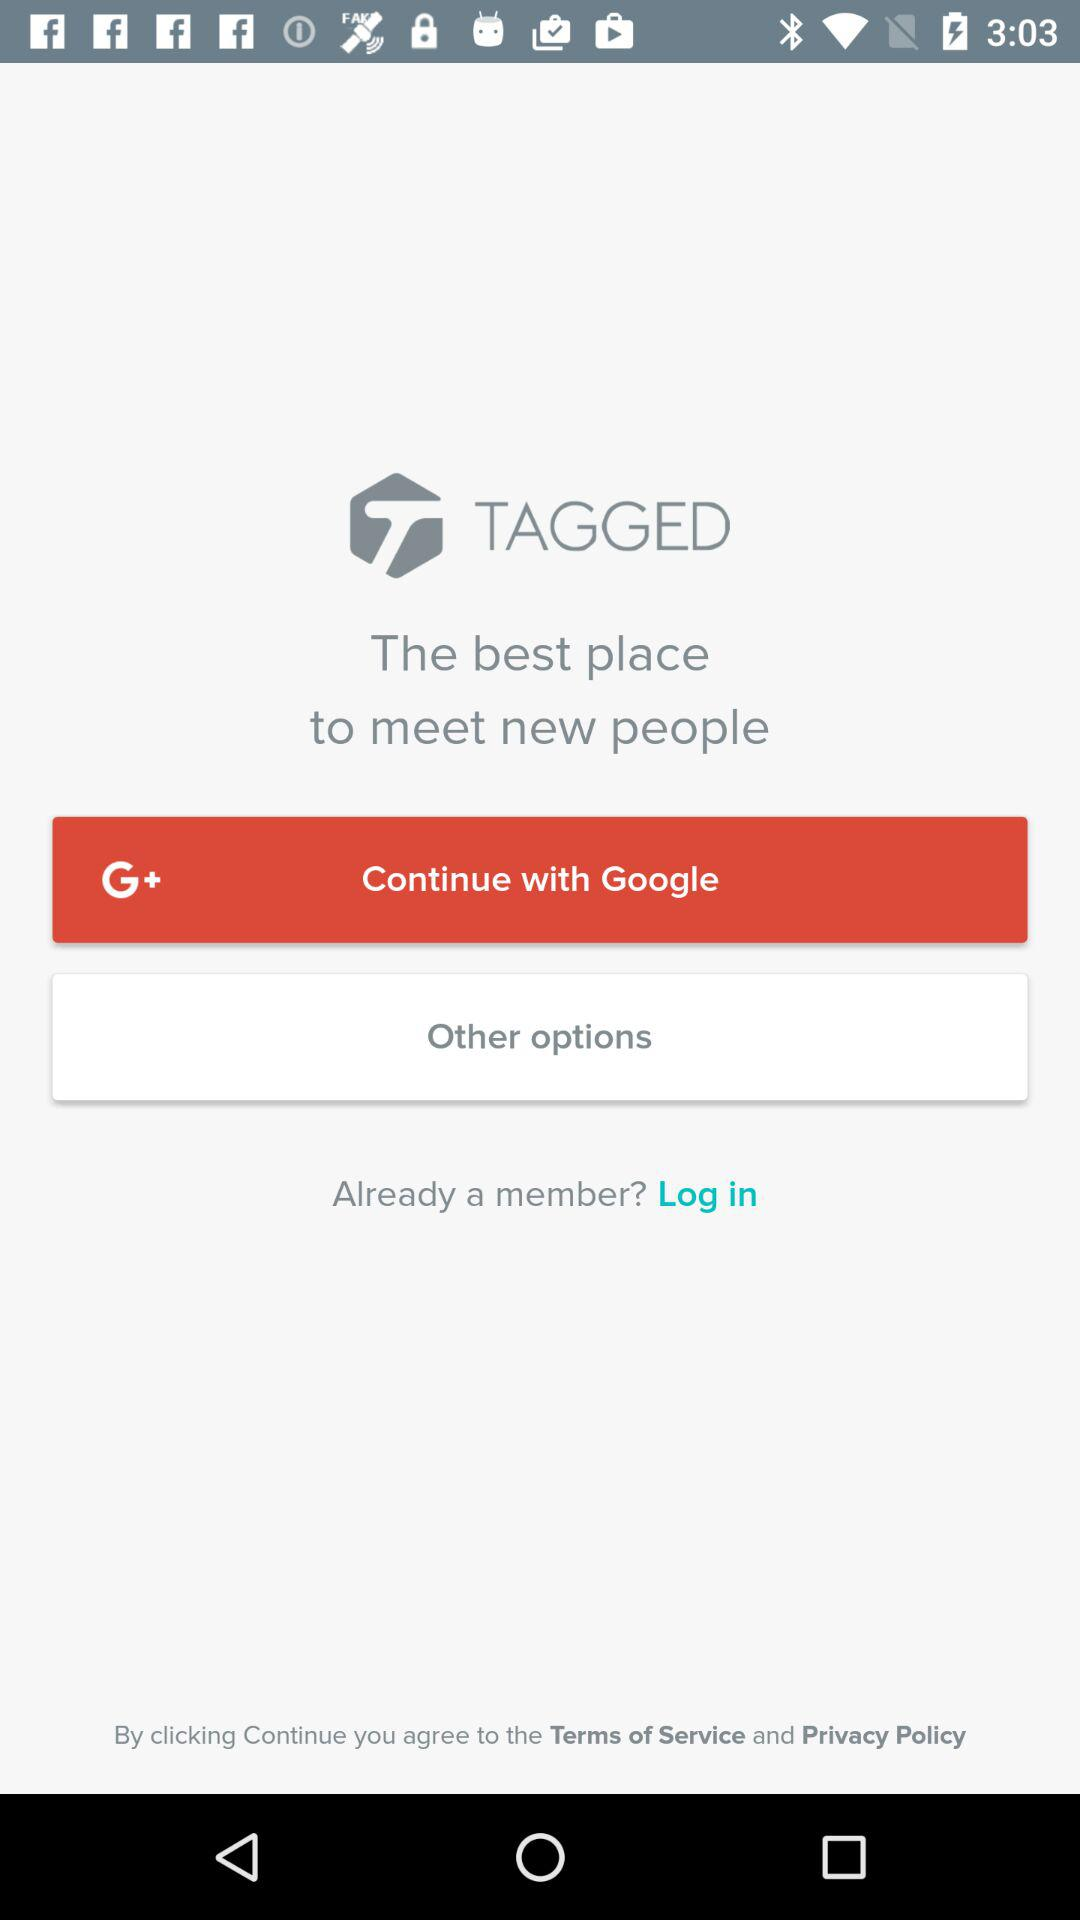What is the app name? The app name is "TAGGED". 